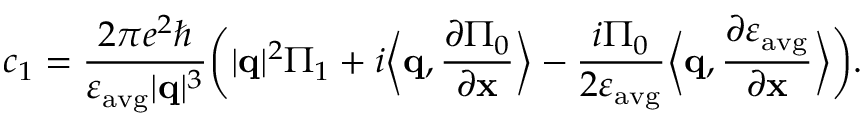<formula> <loc_0><loc_0><loc_500><loc_500>c _ { 1 } = \frac { 2 \pi e ^ { 2 } } { \varepsilon _ { a v g } | q | ^ { 3 } } \left ( | q | ^ { 2 } \Pi _ { 1 } + i \left \langle q , \frac { \partial \Pi _ { 0 } } { \partial x } \right \rangle - \frac { i \Pi _ { 0 } } { 2 \varepsilon _ { a v g } } \left \langle q , \frac { \partial \varepsilon _ { a v g } } { \partial x } \right \rangle \right ) .</formula> 